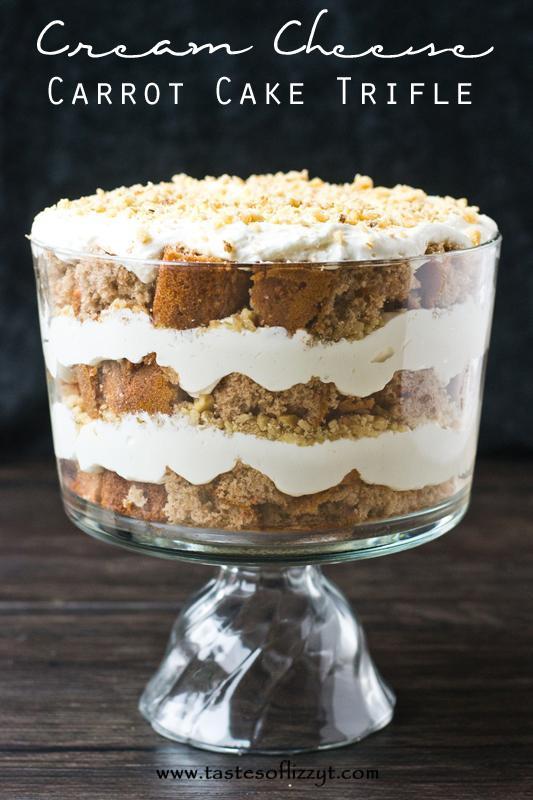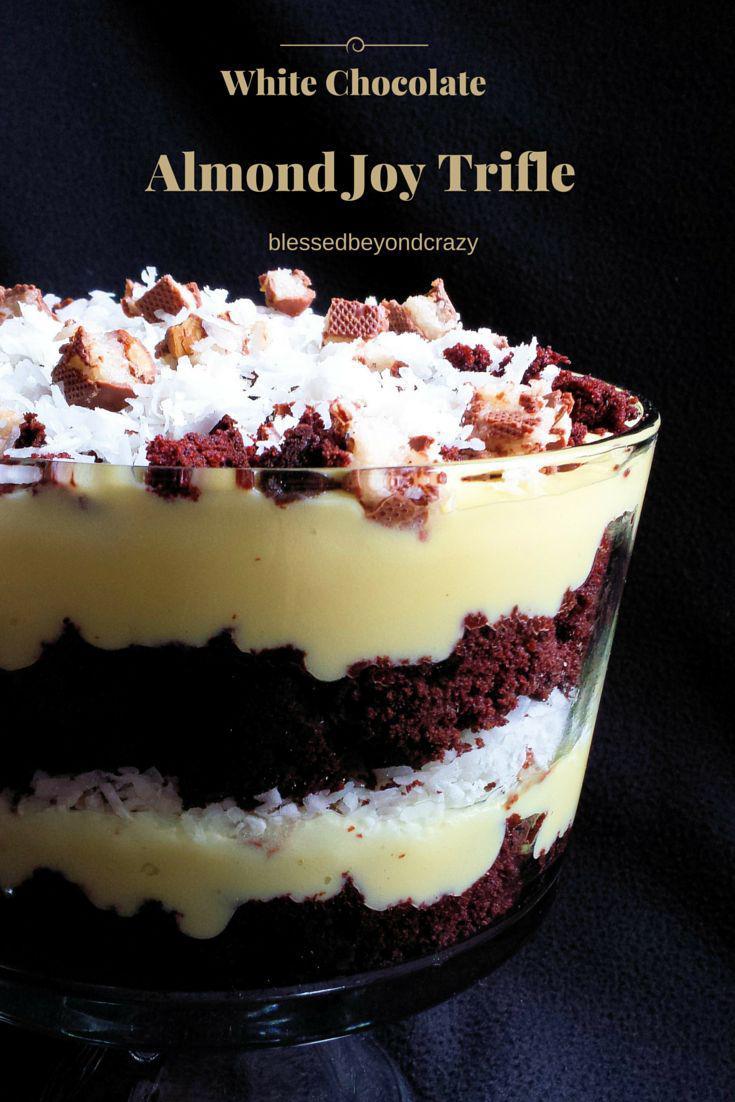The first image is the image on the left, the second image is the image on the right. Considering the images on both sides, is "One of the images features three trifle desserts served individually." valid? Answer yes or no. No. 